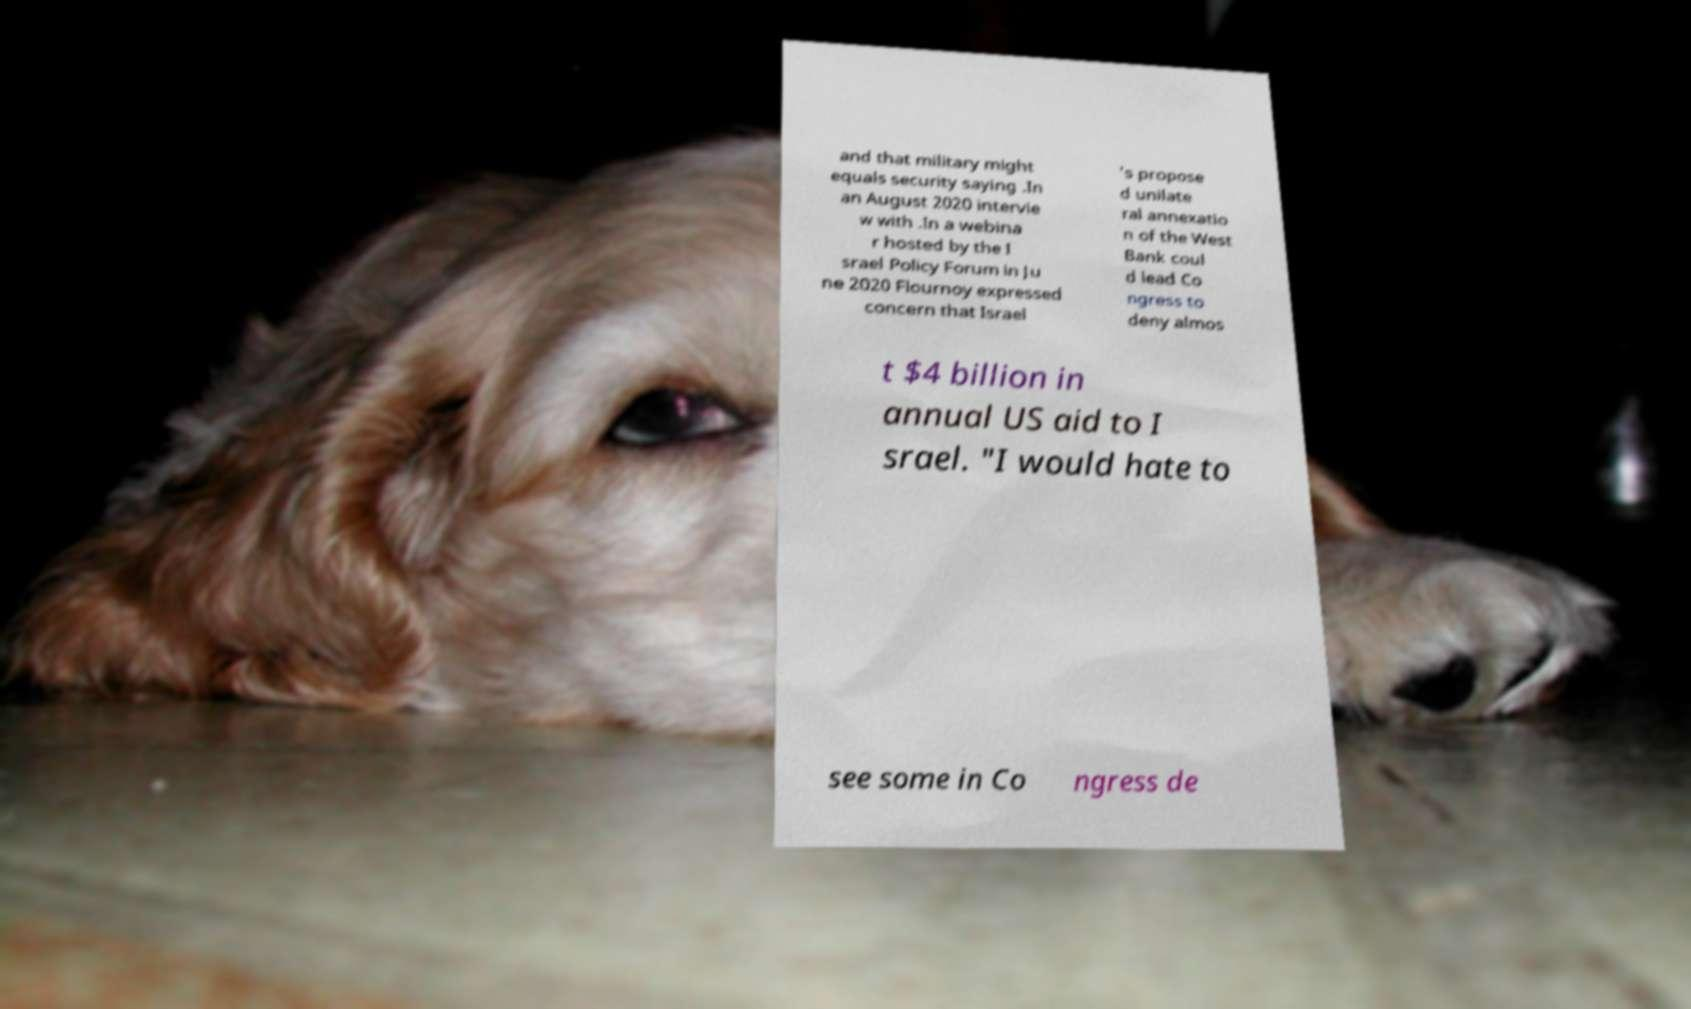I need the written content from this picture converted into text. Can you do that? and that military might equals security saying .In an August 2020 intervie w with .In a webina r hosted by the I srael Policy Forum in Ju ne 2020 Flournoy expressed concern that Israel 's propose d unilate ral annexatio n of the West Bank coul d lead Co ngress to deny almos t $4 billion in annual US aid to I srael. "I would hate to see some in Co ngress de 